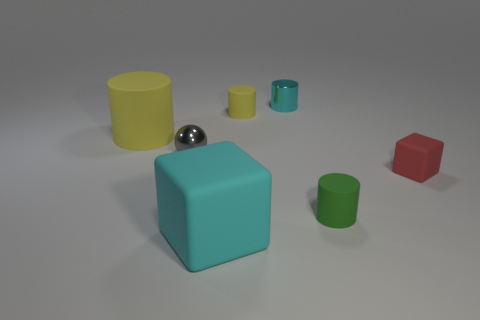What is the color of the other tiny rubber object that is the same shape as the cyan rubber object?
Give a very brief answer. Red. How many tiny rubber objects have the same color as the metallic sphere?
Give a very brief answer. 0. There is a big block; does it have the same color as the matte block that is to the right of the green rubber object?
Offer a terse response. No. What is the shape of the object that is right of the large matte cylinder and left of the big cyan rubber cube?
Provide a short and direct response. Sphere. What material is the large thing that is on the right side of the rubber cylinder that is to the left of the big object in front of the red object made of?
Your response must be concise. Rubber. Are there more large things in front of the big yellow matte object than small gray metallic balls that are behind the tiny ball?
Your response must be concise. Yes. How many other large green cubes have the same material as the big cube?
Your response must be concise. 0. There is a yellow object that is on the right side of the big cyan thing; is its shape the same as the yellow rubber thing in front of the tiny yellow matte cylinder?
Provide a succinct answer. Yes. There is a rubber thing that is behind the large yellow cylinder; what color is it?
Give a very brief answer. Yellow. Is there another big thing that has the same shape as the cyan matte thing?
Ensure brevity in your answer.  No. 